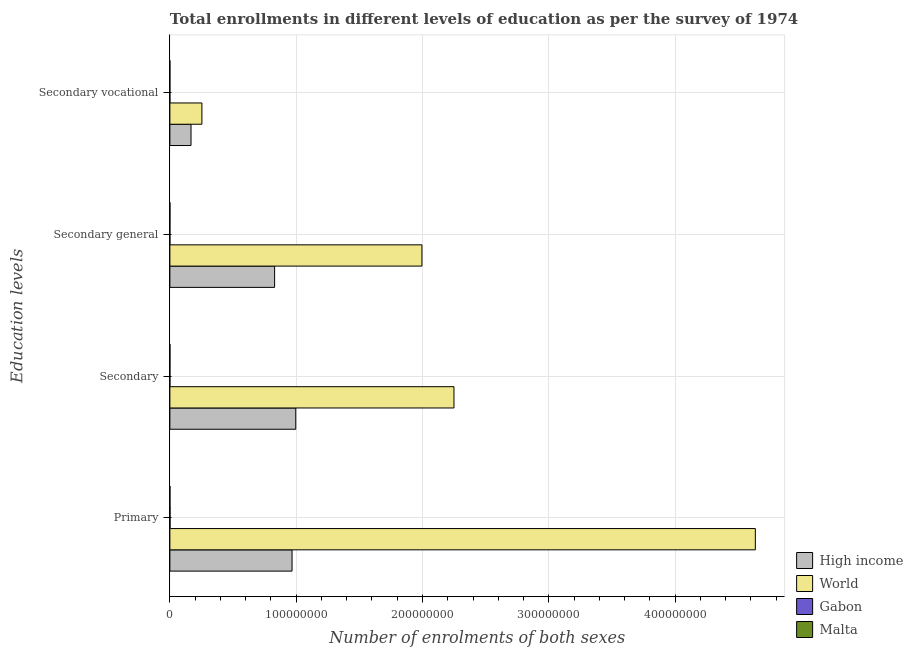How many different coloured bars are there?
Your response must be concise. 4. How many groups of bars are there?
Ensure brevity in your answer.  4. Are the number of bars on each tick of the Y-axis equal?
Your answer should be very brief. Yes. How many bars are there on the 4th tick from the top?
Your response must be concise. 4. How many bars are there on the 4th tick from the bottom?
Provide a succinct answer. 4. What is the label of the 2nd group of bars from the top?
Make the answer very short. Secondary general. What is the number of enrolments in secondary education in Gabon?
Offer a very short reply. 1.75e+04. Across all countries, what is the maximum number of enrolments in secondary vocational education?
Provide a short and direct response. 2.54e+07. Across all countries, what is the minimum number of enrolments in primary education?
Provide a short and direct response. 3.26e+04. In which country was the number of enrolments in secondary vocational education minimum?
Offer a very short reply. Malta. What is the total number of enrolments in secondary education in the graph?
Give a very brief answer. 3.25e+08. What is the difference between the number of enrolments in secondary vocational education in High income and that in Malta?
Your answer should be compact. 1.67e+07. What is the difference between the number of enrolments in secondary vocational education in World and the number of enrolments in secondary general education in Gabon?
Your response must be concise. 2.53e+07. What is the average number of enrolments in primary education per country?
Provide a succinct answer. 1.40e+08. What is the difference between the number of enrolments in primary education and number of enrolments in secondary general education in World?
Keep it short and to the point. 2.64e+08. In how many countries, is the number of enrolments in secondary general education greater than 20000000 ?
Your answer should be compact. 2. What is the ratio of the number of enrolments in secondary vocational education in World to that in High income?
Keep it short and to the point. 1.51. Is the difference between the number of enrolments in secondary vocational education in Gabon and High income greater than the difference between the number of enrolments in secondary general education in Gabon and High income?
Offer a terse response. Yes. What is the difference between the highest and the second highest number of enrolments in secondary education?
Ensure brevity in your answer.  1.25e+08. What is the difference between the highest and the lowest number of enrolments in secondary vocational education?
Ensure brevity in your answer.  2.54e+07. Is the sum of the number of enrolments in secondary vocational education in High income and Malta greater than the maximum number of enrolments in secondary general education across all countries?
Provide a short and direct response. No. What does the 4th bar from the top in Secondary represents?
Make the answer very short. High income. What does the 3rd bar from the bottom in Secondary general represents?
Ensure brevity in your answer.  Gabon. How many bars are there?
Give a very brief answer. 16. Are all the bars in the graph horizontal?
Your response must be concise. Yes. Does the graph contain grids?
Give a very brief answer. Yes. What is the title of the graph?
Provide a succinct answer. Total enrollments in different levels of education as per the survey of 1974. Does "High income" appear as one of the legend labels in the graph?
Your response must be concise. Yes. What is the label or title of the X-axis?
Provide a succinct answer. Number of enrolments of both sexes. What is the label or title of the Y-axis?
Make the answer very short. Education levels. What is the Number of enrolments of both sexes of High income in Primary?
Offer a terse response. 9.67e+07. What is the Number of enrolments of both sexes in World in Primary?
Your answer should be very brief. 4.64e+08. What is the Number of enrolments of both sexes of Gabon in Primary?
Provide a succinct answer. 1.14e+05. What is the Number of enrolments of both sexes of Malta in Primary?
Offer a terse response. 3.26e+04. What is the Number of enrolments of both sexes in High income in Secondary?
Your answer should be very brief. 9.97e+07. What is the Number of enrolments of both sexes in World in Secondary?
Ensure brevity in your answer.  2.25e+08. What is the Number of enrolments of both sexes in Gabon in Secondary?
Your answer should be compact. 1.75e+04. What is the Number of enrolments of both sexes of Malta in Secondary?
Provide a succinct answer. 2.84e+04. What is the Number of enrolments of both sexes of High income in Secondary general?
Give a very brief answer. 8.29e+07. What is the Number of enrolments of both sexes of World in Secondary general?
Give a very brief answer. 2.00e+08. What is the Number of enrolments of both sexes of Gabon in Secondary general?
Give a very brief answer. 1.45e+04. What is the Number of enrolments of both sexes in Malta in Secondary general?
Your answer should be compact. 2.55e+04. What is the Number of enrolments of both sexes of High income in Secondary vocational?
Offer a very short reply. 1.67e+07. What is the Number of enrolments of both sexes of World in Secondary vocational?
Offer a very short reply. 2.54e+07. What is the Number of enrolments of both sexes in Gabon in Secondary vocational?
Offer a very short reply. 3054. What is the Number of enrolments of both sexes in Malta in Secondary vocational?
Offer a very short reply. 2925. Across all Education levels, what is the maximum Number of enrolments of both sexes in High income?
Ensure brevity in your answer.  9.97e+07. Across all Education levels, what is the maximum Number of enrolments of both sexes of World?
Provide a succinct answer. 4.64e+08. Across all Education levels, what is the maximum Number of enrolments of both sexes in Gabon?
Your response must be concise. 1.14e+05. Across all Education levels, what is the maximum Number of enrolments of both sexes in Malta?
Your response must be concise. 3.26e+04. Across all Education levels, what is the minimum Number of enrolments of both sexes of High income?
Offer a very short reply. 1.67e+07. Across all Education levels, what is the minimum Number of enrolments of both sexes of World?
Your answer should be compact. 2.54e+07. Across all Education levels, what is the minimum Number of enrolments of both sexes of Gabon?
Your answer should be compact. 3054. Across all Education levels, what is the minimum Number of enrolments of both sexes in Malta?
Offer a terse response. 2925. What is the total Number of enrolments of both sexes of High income in the graph?
Ensure brevity in your answer.  2.96e+08. What is the total Number of enrolments of both sexes in World in the graph?
Your answer should be very brief. 9.13e+08. What is the total Number of enrolments of both sexes in Gabon in the graph?
Your answer should be very brief. 1.49e+05. What is the total Number of enrolments of both sexes of Malta in the graph?
Your response must be concise. 8.94e+04. What is the difference between the Number of enrolments of both sexes in High income in Primary and that in Secondary?
Offer a very short reply. -2.92e+06. What is the difference between the Number of enrolments of both sexes in World in Primary and that in Secondary?
Provide a short and direct response. 2.39e+08. What is the difference between the Number of enrolments of both sexes of Gabon in Primary and that in Secondary?
Offer a terse response. 9.66e+04. What is the difference between the Number of enrolments of both sexes in Malta in Primary and that in Secondary?
Offer a terse response. 4135. What is the difference between the Number of enrolments of both sexes in High income in Primary and that in Secondary general?
Give a very brief answer. 1.38e+07. What is the difference between the Number of enrolments of both sexes in World in Primary and that in Secondary general?
Keep it short and to the point. 2.64e+08. What is the difference between the Number of enrolments of both sexes in Gabon in Primary and that in Secondary general?
Give a very brief answer. 9.97e+04. What is the difference between the Number of enrolments of both sexes in Malta in Primary and that in Secondary general?
Ensure brevity in your answer.  7060. What is the difference between the Number of enrolments of both sexes of High income in Primary and that in Secondary vocational?
Provide a succinct answer. 8.00e+07. What is the difference between the Number of enrolments of both sexes of World in Primary and that in Secondary vocational?
Make the answer very short. 4.38e+08. What is the difference between the Number of enrolments of both sexes of Gabon in Primary and that in Secondary vocational?
Offer a very short reply. 1.11e+05. What is the difference between the Number of enrolments of both sexes in Malta in Primary and that in Secondary vocational?
Your answer should be compact. 2.96e+04. What is the difference between the Number of enrolments of both sexes in High income in Secondary and that in Secondary general?
Your answer should be very brief. 1.67e+07. What is the difference between the Number of enrolments of both sexes of World in Secondary and that in Secondary general?
Provide a succinct answer. 2.54e+07. What is the difference between the Number of enrolments of both sexes in Gabon in Secondary and that in Secondary general?
Provide a succinct answer. 3054. What is the difference between the Number of enrolments of both sexes in Malta in Secondary and that in Secondary general?
Offer a terse response. 2925. What is the difference between the Number of enrolments of both sexes of High income in Secondary and that in Secondary vocational?
Your response must be concise. 8.29e+07. What is the difference between the Number of enrolments of both sexes in World in Secondary and that in Secondary vocational?
Keep it short and to the point. 2.00e+08. What is the difference between the Number of enrolments of both sexes of Gabon in Secondary and that in Secondary vocational?
Keep it short and to the point. 1.45e+04. What is the difference between the Number of enrolments of both sexes of Malta in Secondary and that in Secondary vocational?
Offer a very short reply. 2.55e+04. What is the difference between the Number of enrolments of both sexes in High income in Secondary general and that in Secondary vocational?
Your answer should be very brief. 6.62e+07. What is the difference between the Number of enrolments of both sexes of World in Secondary general and that in Secondary vocational?
Provide a succinct answer. 1.74e+08. What is the difference between the Number of enrolments of both sexes in Gabon in Secondary general and that in Secondary vocational?
Provide a short and direct response. 1.14e+04. What is the difference between the Number of enrolments of both sexes in Malta in Secondary general and that in Secondary vocational?
Ensure brevity in your answer.  2.26e+04. What is the difference between the Number of enrolments of both sexes in High income in Primary and the Number of enrolments of both sexes in World in Secondary?
Ensure brevity in your answer.  -1.28e+08. What is the difference between the Number of enrolments of both sexes in High income in Primary and the Number of enrolments of both sexes in Gabon in Secondary?
Keep it short and to the point. 9.67e+07. What is the difference between the Number of enrolments of both sexes of High income in Primary and the Number of enrolments of both sexes of Malta in Secondary?
Provide a short and direct response. 9.67e+07. What is the difference between the Number of enrolments of both sexes in World in Primary and the Number of enrolments of both sexes in Gabon in Secondary?
Ensure brevity in your answer.  4.64e+08. What is the difference between the Number of enrolments of both sexes of World in Primary and the Number of enrolments of both sexes of Malta in Secondary?
Your response must be concise. 4.64e+08. What is the difference between the Number of enrolments of both sexes in Gabon in Primary and the Number of enrolments of both sexes in Malta in Secondary?
Provide a succinct answer. 8.57e+04. What is the difference between the Number of enrolments of both sexes in High income in Primary and the Number of enrolments of both sexes in World in Secondary general?
Ensure brevity in your answer.  -1.03e+08. What is the difference between the Number of enrolments of both sexes of High income in Primary and the Number of enrolments of both sexes of Gabon in Secondary general?
Ensure brevity in your answer.  9.67e+07. What is the difference between the Number of enrolments of both sexes in High income in Primary and the Number of enrolments of both sexes in Malta in Secondary general?
Offer a terse response. 9.67e+07. What is the difference between the Number of enrolments of both sexes in World in Primary and the Number of enrolments of both sexes in Gabon in Secondary general?
Offer a terse response. 4.64e+08. What is the difference between the Number of enrolments of both sexes of World in Primary and the Number of enrolments of both sexes of Malta in Secondary general?
Give a very brief answer. 4.64e+08. What is the difference between the Number of enrolments of both sexes of Gabon in Primary and the Number of enrolments of both sexes of Malta in Secondary general?
Ensure brevity in your answer.  8.87e+04. What is the difference between the Number of enrolments of both sexes of High income in Primary and the Number of enrolments of both sexes of World in Secondary vocational?
Offer a terse response. 7.14e+07. What is the difference between the Number of enrolments of both sexes in High income in Primary and the Number of enrolments of both sexes in Gabon in Secondary vocational?
Provide a succinct answer. 9.67e+07. What is the difference between the Number of enrolments of both sexes in High income in Primary and the Number of enrolments of both sexes in Malta in Secondary vocational?
Give a very brief answer. 9.67e+07. What is the difference between the Number of enrolments of both sexes in World in Primary and the Number of enrolments of both sexes in Gabon in Secondary vocational?
Your response must be concise. 4.64e+08. What is the difference between the Number of enrolments of both sexes of World in Primary and the Number of enrolments of both sexes of Malta in Secondary vocational?
Your answer should be compact. 4.64e+08. What is the difference between the Number of enrolments of both sexes in Gabon in Primary and the Number of enrolments of both sexes in Malta in Secondary vocational?
Your answer should be compact. 1.11e+05. What is the difference between the Number of enrolments of both sexes in High income in Secondary and the Number of enrolments of both sexes in World in Secondary general?
Make the answer very short. -9.99e+07. What is the difference between the Number of enrolments of both sexes of High income in Secondary and the Number of enrolments of both sexes of Gabon in Secondary general?
Give a very brief answer. 9.96e+07. What is the difference between the Number of enrolments of both sexes of High income in Secondary and the Number of enrolments of both sexes of Malta in Secondary general?
Ensure brevity in your answer.  9.96e+07. What is the difference between the Number of enrolments of both sexes in World in Secondary and the Number of enrolments of both sexes in Gabon in Secondary general?
Offer a very short reply. 2.25e+08. What is the difference between the Number of enrolments of both sexes in World in Secondary and the Number of enrolments of both sexes in Malta in Secondary general?
Your answer should be very brief. 2.25e+08. What is the difference between the Number of enrolments of both sexes of Gabon in Secondary and the Number of enrolments of both sexes of Malta in Secondary general?
Your response must be concise. -7965. What is the difference between the Number of enrolments of both sexes of High income in Secondary and the Number of enrolments of both sexes of World in Secondary vocational?
Provide a short and direct response. 7.43e+07. What is the difference between the Number of enrolments of both sexes in High income in Secondary and the Number of enrolments of both sexes in Gabon in Secondary vocational?
Ensure brevity in your answer.  9.97e+07. What is the difference between the Number of enrolments of both sexes of High income in Secondary and the Number of enrolments of both sexes of Malta in Secondary vocational?
Your answer should be very brief. 9.97e+07. What is the difference between the Number of enrolments of both sexes in World in Secondary and the Number of enrolments of both sexes in Gabon in Secondary vocational?
Ensure brevity in your answer.  2.25e+08. What is the difference between the Number of enrolments of both sexes of World in Secondary and the Number of enrolments of both sexes of Malta in Secondary vocational?
Offer a terse response. 2.25e+08. What is the difference between the Number of enrolments of both sexes of Gabon in Secondary and the Number of enrolments of both sexes of Malta in Secondary vocational?
Your answer should be compact. 1.46e+04. What is the difference between the Number of enrolments of both sexes in High income in Secondary general and the Number of enrolments of both sexes in World in Secondary vocational?
Offer a terse response. 5.76e+07. What is the difference between the Number of enrolments of both sexes of High income in Secondary general and the Number of enrolments of both sexes of Gabon in Secondary vocational?
Your answer should be compact. 8.29e+07. What is the difference between the Number of enrolments of both sexes of High income in Secondary general and the Number of enrolments of both sexes of Malta in Secondary vocational?
Your response must be concise. 8.29e+07. What is the difference between the Number of enrolments of both sexes of World in Secondary general and the Number of enrolments of both sexes of Gabon in Secondary vocational?
Provide a short and direct response. 2.00e+08. What is the difference between the Number of enrolments of both sexes of World in Secondary general and the Number of enrolments of both sexes of Malta in Secondary vocational?
Give a very brief answer. 2.00e+08. What is the difference between the Number of enrolments of both sexes of Gabon in Secondary general and the Number of enrolments of both sexes of Malta in Secondary vocational?
Provide a succinct answer. 1.16e+04. What is the average Number of enrolments of both sexes in High income per Education levels?
Ensure brevity in your answer.  7.40e+07. What is the average Number of enrolments of both sexes in World per Education levels?
Keep it short and to the point. 2.28e+08. What is the average Number of enrolments of both sexes of Gabon per Education levels?
Offer a terse response. 3.73e+04. What is the average Number of enrolments of both sexes of Malta per Education levels?
Give a very brief answer. 2.24e+04. What is the difference between the Number of enrolments of both sexes of High income and Number of enrolments of both sexes of World in Primary?
Make the answer very short. -3.67e+08. What is the difference between the Number of enrolments of both sexes in High income and Number of enrolments of both sexes in Gabon in Primary?
Ensure brevity in your answer.  9.66e+07. What is the difference between the Number of enrolments of both sexes of High income and Number of enrolments of both sexes of Malta in Primary?
Your answer should be very brief. 9.67e+07. What is the difference between the Number of enrolments of both sexes in World and Number of enrolments of both sexes in Gabon in Primary?
Offer a terse response. 4.63e+08. What is the difference between the Number of enrolments of both sexes in World and Number of enrolments of both sexes in Malta in Primary?
Ensure brevity in your answer.  4.64e+08. What is the difference between the Number of enrolments of both sexes of Gabon and Number of enrolments of both sexes of Malta in Primary?
Provide a succinct answer. 8.16e+04. What is the difference between the Number of enrolments of both sexes of High income and Number of enrolments of both sexes of World in Secondary?
Give a very brief answer. -1.25e+08. What is the difference between the Number of enrolments of both sexes in High income and Number of enrolments of both sexes in Gabon in Secondary?
Make the answer very short. 9.96e+07. What is the difference between the Number of enrolments of both sexes of High income and Number of enrolments of both sexes of Malta in Secondary?
Provide a short and direct response. 9.96e+07. What is the difference between the Number of enrolments of both sexes in World and Number of enrolments of both sexes in Gabon in Secondary?
Provide a short and direct response. 2.25e+08. What is the difference between the Number of enrolments of both sexes of World and Number of enrolments of both sexes of Malta in Secondary?
Ensure brevity in your answer.  2.25e+08. What is the difference between the Number of enrolments of both sexes of Gabon and Number of enrolments of both sexes of Malta in Secondary?
Make the answer very short. -1.09e+04. What is the difference between the Number of enrolments of both sexes in High income and Number of enrolments of both sexes in World in Secondary general?
Provide a short and direct response. -1.17e+08. What is the difference between the Number of enrolments of both sexes in High income and Number of enrolments of both sexes in Gabon in Secondary general?
Offer a very short reply. 8.29e+07. What is the difference between the Number of enrolments of both sexes of High income and Number of enrolments of both sexes of Malta in Secondary general?
Your response must be concise. 8.29e+07. What is the difference between the Number of enrolments of both sexes in World and Number of enrolments of both sexes in Gabon in Secondary general?
Keep it short and to the point. 2.00e+08. What is the difference between the Number of enrolments of both sexes of World and Number of enrolments of both sexes of Malta in Secondary general?
Make the answer very short. 2.00e+08. What is the difference between the Number of enrolments of both sexes of Gabon and Number of enrolments of both sexes of Malta in Secondary general?
Provide a short and direct response. -1.10e+04. What is the difference between the Number of enrolments of both sexes of High income and Number of enrolments of both sexes of World in Secondary vocational?
Give a very brief answer. -8.62e+06. What is the difference between the Number of enrolments of both sexes in High income and Number of enrolments of both sexes in Gabon in Secondary vocational?
Provide a succinct answer. 1.67e+07. What is the difference between the Number of enrolments of both sexes in High income and Number of enrolments of both sexes in Malta in Secondary vocational?
Your answer should be compact. 1.67e+07. What is the difference between the Number of enrolments of both sexes of World and Number of enrolments of both sexes of Gabon in Secondary vocational?
Your answer should be compact. 2.54e+07. What is the difference between the Number of enrolments of both sexes in World and Number of enrolments of both sexes in Malta in Secondary vocational?
Your answer should be very brief. 2.54e+07. What is the difference between the Number of enrolments of both sexes of Gabon and Number of enrolments of both sexes of Malta in Secondary vocational?
Your response must be concise. 129. What is the ratio of the Number of enrolments of both sexes in High income in Primary to that in Secondary?
Provide a succinct answer. 0.97. What is the ratio of the Number of enrolments of both sexes of World in Primary to that in Secondary?
Keep it short and to the point. 2.06. What is the ratio of the Number of enrolments of both sexes of Gabon in Primary to that in Secondary?
Offer a very short reply. 6.51. What is the ratio of the Number of enrolments of both sexes in Malta in Primary to that in Secondary?
Make the answer very short. 1.15. What is the ratio of the Number of enrolments of both sexes in High income in Primary to that in Secondary general?
Offer a terse response. 1.17. What is the ratio of the Number of enrolments of both sexes of World in Primary to that in Secondary general?
Provide a short and direct response. 2.32. What is the ratio of the Number of enrolments of both sexes in Gabon in Primary to that in Secondary general?
Ensure brevity in your answer.  7.88. What is the ratio of the Number of enrolments of both sexes of Malta in Primary to that in Secondary general?
Your answer should be compact. 1.28. What is the ratio of the Number of enrolments of both sexes of High income in Primary to that in Secondary vocational?
Ensure brevity in your answer.  5.78. What is the ratio of the Number of enrolments of both sexes in World in Primary to that in Secondary vocational?
Ensure brevity in your answer.  18.28. What is the ratio of the Number of enrolments of both sexes in Gabon in Primary to that in Secondary vocational?
Your answer should be very brief. 37.38. What is the ratio of the Number of enrolments of both sexes of Malta in Primary to that in Secondary vocational?
Offer a very short reply. 11.13. What is the ratio of the Number of enrolments of both sexes in High income in Secondary to that in Secondary general?
Ensure brevity in your answer.  1.2. What is the ratio of the Number of enrolments of both sexes of World in Secondary to that in Secondary general?
Give a very brief answer. 1.13. What is the ratio of the Number of enrolments of both sexes of Gabon in Secondary to that in Secondary general?
Give a very brief answer. 1.21. What is the ratio of the Number of enrolments of both sexes in Malta in Secondary to that in Secondary general?
Give a very brief answer. 1.11. What is the ratio of the Number of enrolments of both sexes of High income in Secondary to that in Secondary vocational?
Offer a terse response. 5.95. What is the ratio of the Number of enrolments of both sexes of World in Secondary to that in Secondary vocational?
Make the answer very short. 8.87. What is the ratio of the Number of enrolments of both sexes of Gabon in Secondary to that in Secondary vocational?
Keep it short and to the point. 5.74. What is the ratio of the Number of enrolments of both sexes of Malta in Secondary to that in Secondary vocational?
Offer a very short reply. 9.72. What is the ratio of the Number of enrolments of both sexes in High income in Secondary general to that in Secondary vocational?
Your answer should be compact. 4.95. What is the ratio of the Number of enrolments of both sexes of World in Secondary general to that in Secondary vocational?
Your answer should be compact. 7.87. What is the ratio of the Number of enrolments of both sexes of Gabon in Secondary general to that in Secondary vocational?
Your answer should be compact. 4.74. What is the ratio of the Number of enrolments of both sexes in Malta in Secondary general to that in Secondary vocational?
Offer a terse response. 8.72. What is the difference between the highest and the second highest Number of enrolments of both sexes of High income?
Keep it short and to the point. 2.92e+06. What is the difference between the highest and the second highest Number of enrolments of both sexes of World?
Ensure brevity in your answer.  2.39e+08. What is the difference between the highest and the second highest Number of enrolments of both sexes of Gabon?
Make the answer very short. 9.66e+04. What is the difference between the highest and the second highest Number of enrolments of both sexes in Malta?
Provide a short and direct response. 4135. What is the difference between the highest and the lowest Number of enrolments of both sexes of High income?
Make the answer very short. 8.29e+07. What is the difference between the highest and the lowest Number of enrolments of both sexes in World?
Your response must be concise. 4.38e+08. What is the difference between the highest and the lowest Number of enrolments of both sexes in Gabon?
Provide a succinct answer. 1.11e+05. What is the difference between the highest and the lowest Number of enrolments of both sexes of Malta?
Give a very brief answer. 2.96e+04. 